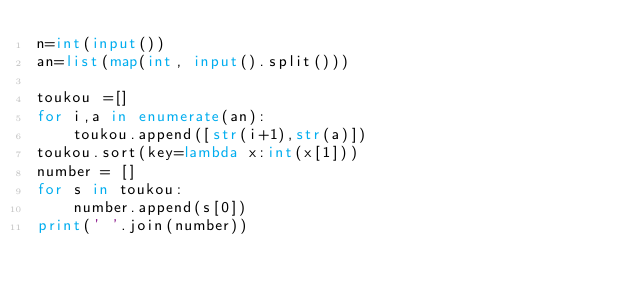Convert code to text. <code><loc_0><loc_0><loc_500><loc_500><_Python_>n=int(input())
an=list(map(int, input().split()))

toukou =[]
for i,a in enumerate(an):
    toukou.append([str(i+1),str(a)])
toukou.sort(key=lambda x:int(x[1]))
number = []
for s in toukou:
    number.append(s[0])
print(' '.join(number))</code> 